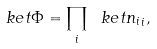<formula> <loc_0><loc_0><loc_500><loc_500>\ k e t { \Phi } = \prod _ { i } \ k e t { n _ { i } } _ { i } ,</formula> 